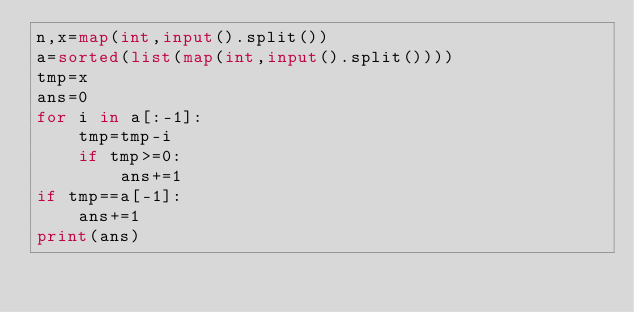Convert code to text. <code><loc_0><loc_0><loc_500><loc_500><_Python_>n,x=map(int,input().split())
a=sorted(list(map(int,input().split())))
tmp=x
ans=0
for i in a[:-1]:
    tmp=tmp-i
    if tmp>=0:
        ans+=1
if tmp==a[-1]:
    ans+=1
print(ans)</code> 